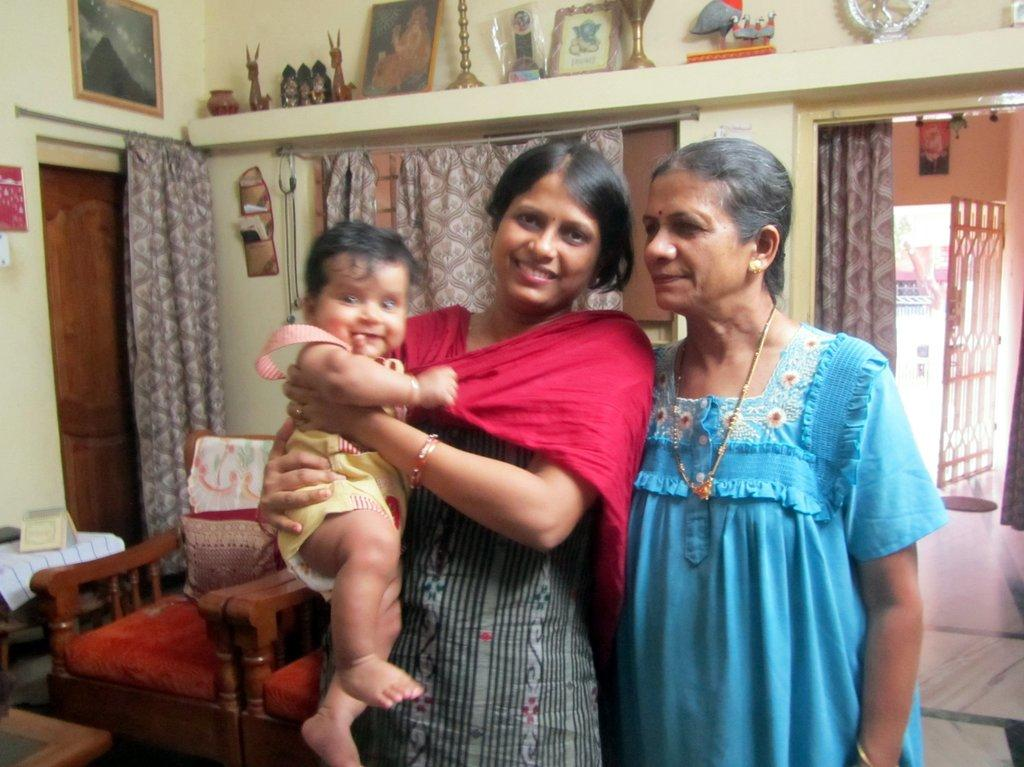How many women are in the image? There are two women in the image. What is one of the women doing in the image? One of the women is holding a baby. What can be seen in the background of the image? There are two sofas, a door, a wall, and items on a rack in the background of the image. What type of card is the baby holding in the image? There is no card present in the image; the baby is not holding anything. 